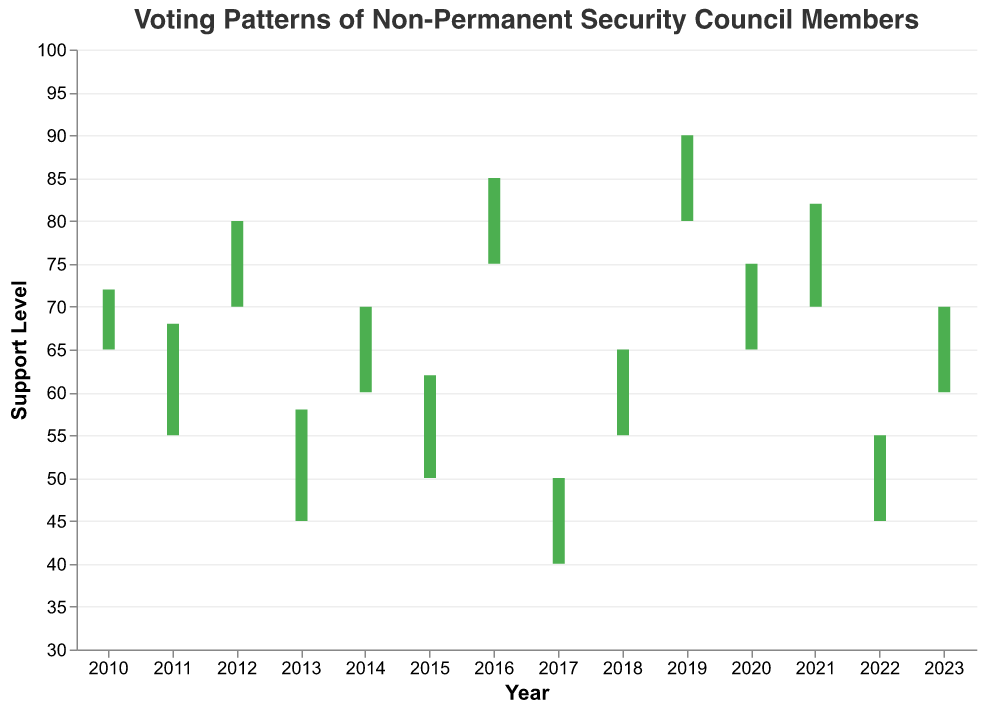What is the title of the chart? The title of the chart is located at the top and it is clearly stated there.
Answer: Voting Patterns of Non-Permanent Security Council Members How many countries' voting patterns are displayed in the chart? Each country corresponds to one data point per year, and there are unique labels for each year from 2010 to 2023. Counting these labels gives the number of countries.
Answer: 14 Which country had the highest closing support level? The highest closing support level corresponds to the tallest bar on the chart's closing end, which reaches the highest value on the y-axis, marked by "Close".
Answer: Belgium Between which years did Nigeria show an increase in its support level from opening to closing values? Looking at the color of the bars for Nigeria, if the color is green, it indicates an increase (close > open). Check the years and support levels for Nigeria.
Answer: 2011 Which country had the greatest variation in support levels within a single year? The greatest variation in support levels can be identified by the longest vertical line, representing high to low support levels within a year.
Answer: Belgium What is the average closing support level for the countries displayed? Sum up all the closing support levels and divide by the number of years (data points). The closing levels are 72, 68, 80, 58, 70, 62, 85, 50, 65, 90, 75, 82, 55, 70. Calculate the sum first and then divide by 14.
Answer: 70.6 Which country had the lowest opening support level, and in what year? The lowest opening support level is marked by the lowest point of the bar's starting position. Check the label for the corresponding country and year.
Answer: Egypt, 2017 In which year was there the smallest gap between the high and low support levels? The smallest gap can be identified by finding the shortest vertical line on the chart, representing the high to low range for the year.
Answer: Ethiopia, 2018 How did Vietnam's support levels change from open to close in 2020? Find the bar associated with Vietnam in 2020 and observe the color of the bar. A green bar indicates an increase while a red bar indicates a decrease.
Answer: Increased Which two countries had the highest and lowest support close in 2015 and 2017 respectively? Compare the closing support levels for the years 2015 and 2017 to find the highest and lowest respective values.
Answer: Malaysia (2015, 62) and Egypt (2017, 50) What is the median closing support level? To find the median, list all closing support levels in ascending order and find the middle value. If there is an odd number of values, the median is the middle one; if even, the median is the average of the two middle values. The closing levels are 72, 68, 80, 58, 70, 62, 85, 50, 65, 90, 75, 82, 55, 70.
Answer: 70 